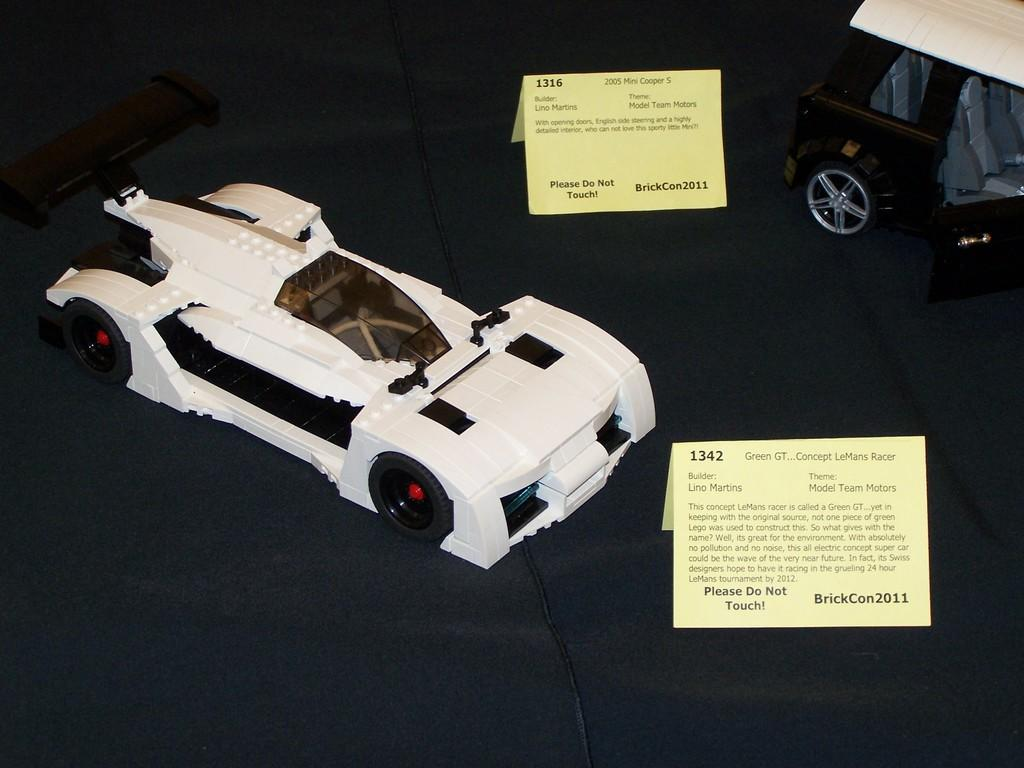How many toy cars are present in the image? There are 2 toy cars in the image. What else can be seen with writing in the image? There are 2 tabs with writing in the image. Can you describe any other object in the image? Yes, there is a wire visible in the image. What type of news can be heard coming from the toy cars in the image? There is no indication in the image that the toy cars are producing any news or sounds. 